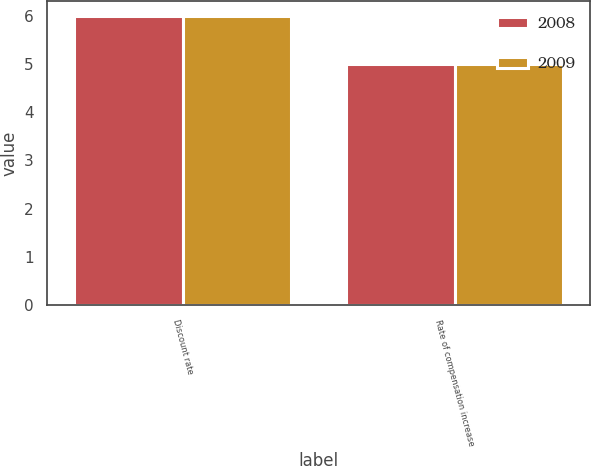Convert chart. <chart><loc_0><loc_0><loc_500><loc_500><stacked_bar_chart><ecel><fcel>Discount rate<fcel>Rate of compensation increase<nl><fcel>2008<fcel>6<fcel>5<nl><fcel>2009<fcel>6<fcel>5<nl></chart> 